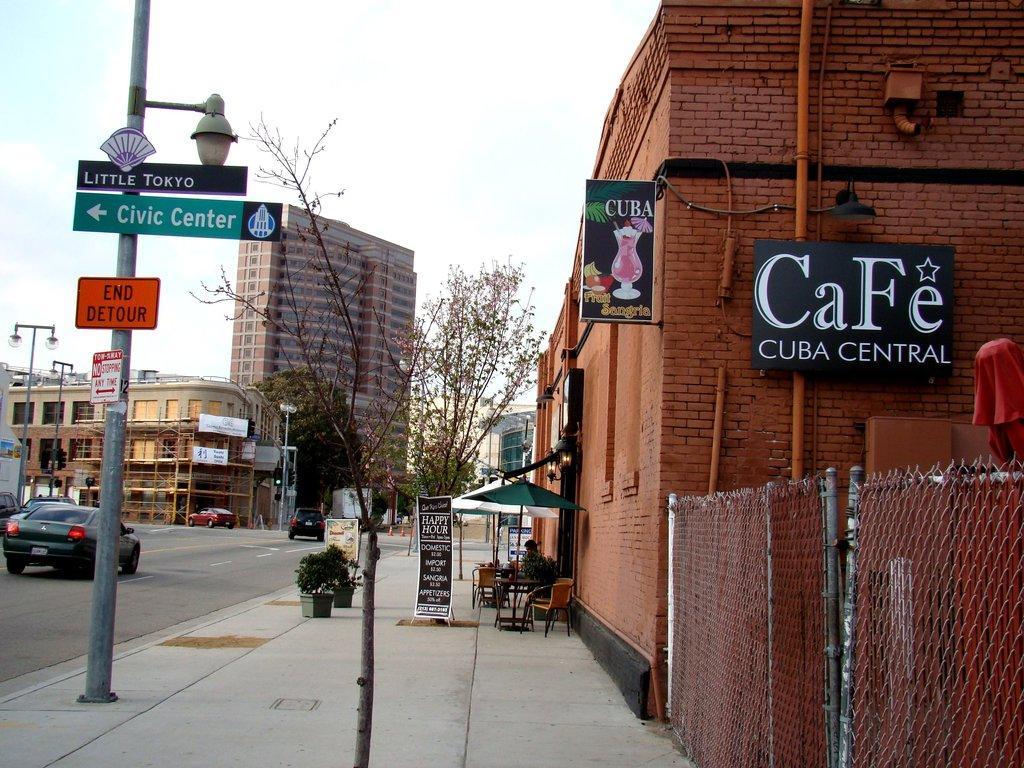How would you summarize this image in a sentence or two? This image is clicked on the road. To the right, there is a building. To the left, there is a car moving on the road. In the background, there are buildings. At the top, there is a sky. 